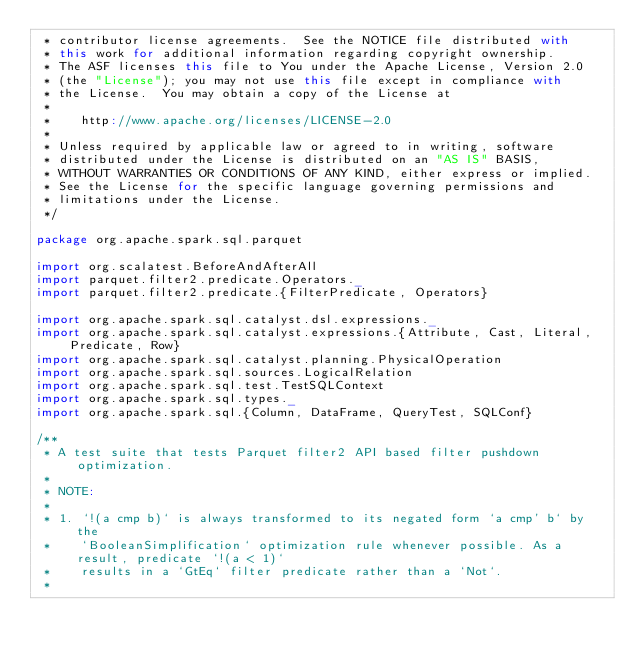<code> <loc_0><loc_0><loc_500><loc_500><_Scala_> * contributor license agreements.  See the NOTICE file distributed with
 * this work for additional information regarding copyright ownership.
 * The ASF licenses this file to You under the Apache License, Version 2.0
 * (the "License"); you may not use this file except in compliance with
 * the License.  You may obtain a copy of the License at
 *
 *    http://www.apache.org/licenses/LICENSE-2.0
 *
 * Unless required by applicable law or agreed to in writing, software
 * distributed under the License is distributed on an "AS IS" BASIS,
 * WITHOUT WARRANTIES OR CONDITIONS OF ANY KIND, either express or implied.
 * See the License for the specific language governing permissions and
 * limitations under the License.
 */

package org.apache.spark.sql.parquet

import org.scalatest.BeforeAndAfterAll
import parquet.filter2.predicate.Operators._
import parquet.filter2.predicate.{FilterPredicate, Operators}

import org.apache.spark.sql.catalyst.dsl.expressions._
import org.apache.spark.sql.catalyst.expressions.{Attribute, Cast, Literal, Predicate, Row}
import org.apache.spark.sql.catalyst.planning.PhysicalOperation
import org.apache.spark.sql.sources.LogicalRelation
import org.apache.spark.sql.test.TestSQLContext
import org.apache.spark.sql.types._
import org.apache.spark.sql.{Column, DataFrame, QueryTest, SQLConf}

/**
 * A test suite that tests Parquet filter2 API based filter pushdown optimization.
 *
 * NOTE:
 *
 * 1. `!(a cmp b)` is always transformed to its negated form `a cmp' b` by the
 *    `BooleanSimplification` optimization rule whenever possible. As a result, predicate `!(a < 1)`
 *    results in a `GtEq` filter predicate rather than a `Not`.
 *</code> 